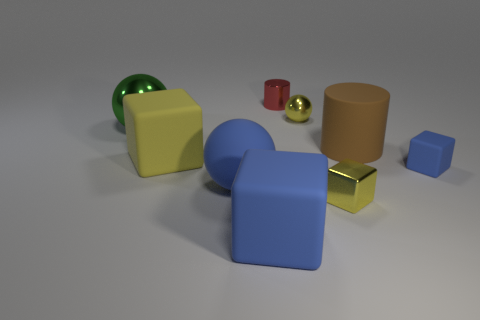Can you describe the composition of the scene and how the objects are arranged? The composition is simple yet deliberate. Objects are arranged in a scattered fashion across a flat surface, with varying distances between them. The placement of objects creates a rhythm and leads the viewer's eye through the scene. Objects of different shapes, sizes, and colors provide visual interest and balance without overcrowding the space. 